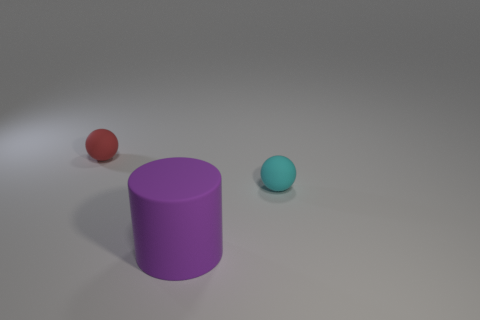Add 2 small red balls. How many objects exist? 5 Subtract all cylinders. How many objects are left? 2 Subtract 0 gray balls. How many objects are left? 3 Subtract all small cyan shiny cubes. Subtract all red objects. How many objects are left? 2 Add 1 matte cylinders. How many matte cylinders are left? 2 Add 3 tiny rubber balls. How many tiny rubber balls exist? 5 